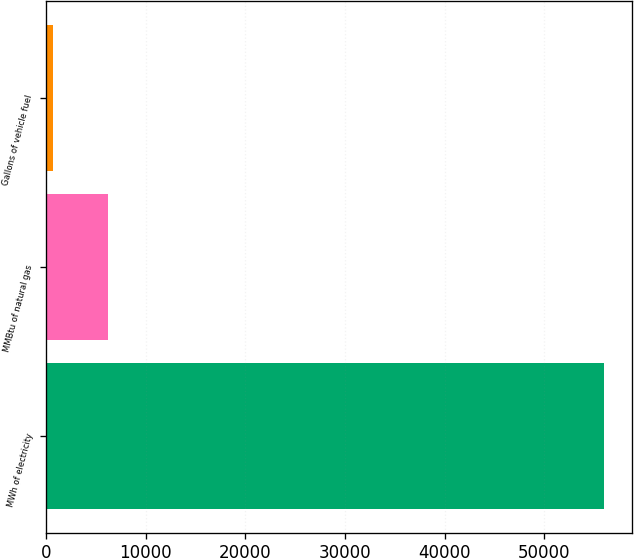Convert chart to OTSL. <chart><loc_0><loc_0><loc_500><loc_500><bar_chart><fcel>MWh of electricity<fcel>MMBtu of natural gas<fcel>Gallons of vehicle fuel<nl><fcel>55976<fcel>6211.4<fcel>682<nl></chart> 